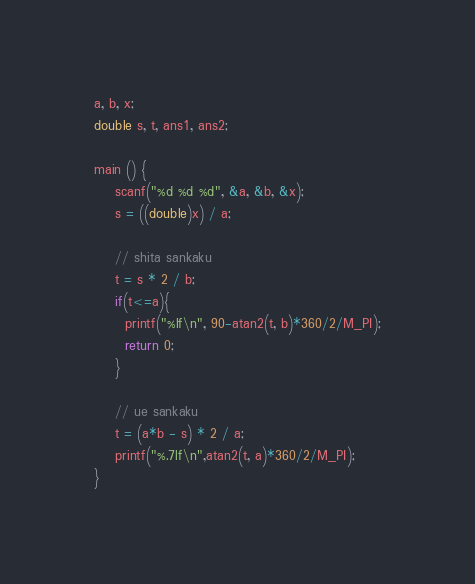<code> <loc_0><loc_0><loc_500><loc_500><_C_>a, b, x;
double s, t, ans1, ans2;

main () {
	scanf("%d %d %d", &a, &b, &x);
	s = ((double)x) / a;
	
	// shita sankaku
	t = s * 2 / b;
	if(t<=a){
	  printf("%lf\n", 90-atan2(t, b)*360/2/M_PI);
	  return 0;
	}
	
	// ue sankaku
	t = (a*b - s) * 2 / a;
	printf("%.7lf\n",atan2(t, a)*360/2/M_PI);
}
</code> 